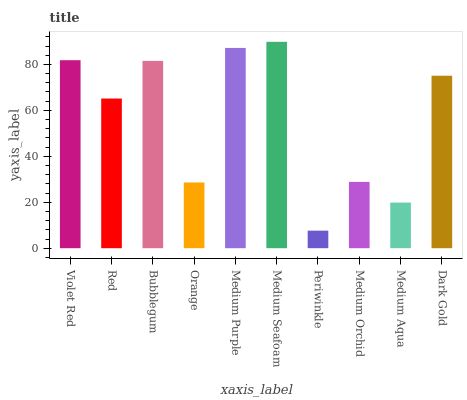Is Periwinkle the minimum?
Answer yes or no. Yes. Is Medium Seafoam the maximum?
Answer yes or no. Yes. Is Red the minimum?
Answer yes or no. No. Is Red the maximum?
Answer yes or no. No. Is Violet Red greater than Red?
Answer yes or no. Yes. Is Red less than Violet Red?
Answer yes or no. Yes. Is Red greater than Violet Red?
Answer yes or no. No. Is Violet Red less than Red?
Answer yes or no. No. Is Dark Gold the high median?
Answer yes or no. Yes. Is Red the low median?
Answer yes or no. Yes. Is Medium Seafoam the high median?
Answer yes or no. No. Is Orange the low median?
Answer yes or no. No. 